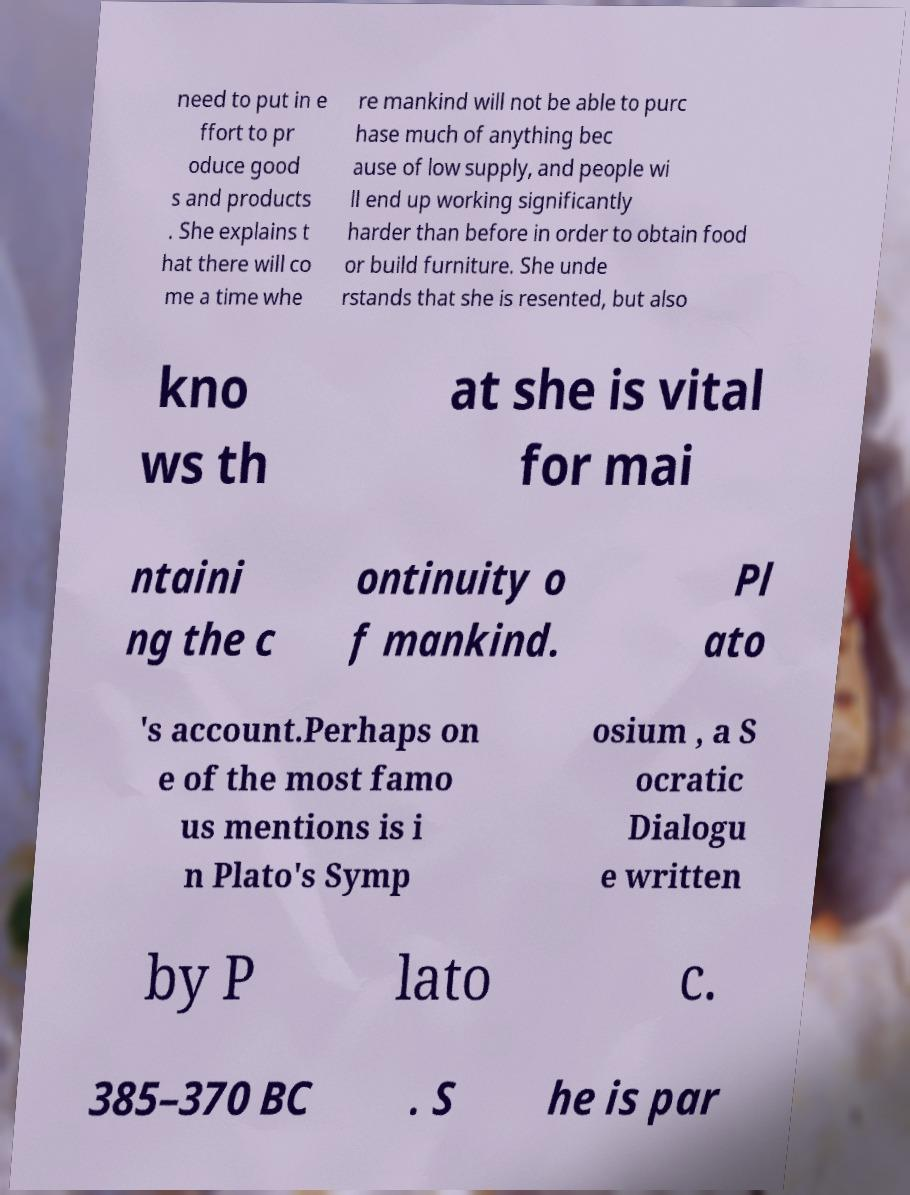Please identify and transcribe the text found in this image. need to put in e ffort to pr oduce good s and products . She explains t hat there will co me a time whe re mankind will not be able to purc hase much of anything bec ause of low supply, and people wi ll end up working significantly harder than before in order to obtain food or build furniture. She unde rstands that she is resented, but also kno ws th at she is vital for mai ntaini ng the c ontinuity o f mankind. Pl ato 's account.Perhaps on e of the most famo us mentions is i n Plato's Symp osium , a S ocratic Dialogu e written by P lato c. 385–370 BC . S he is par 